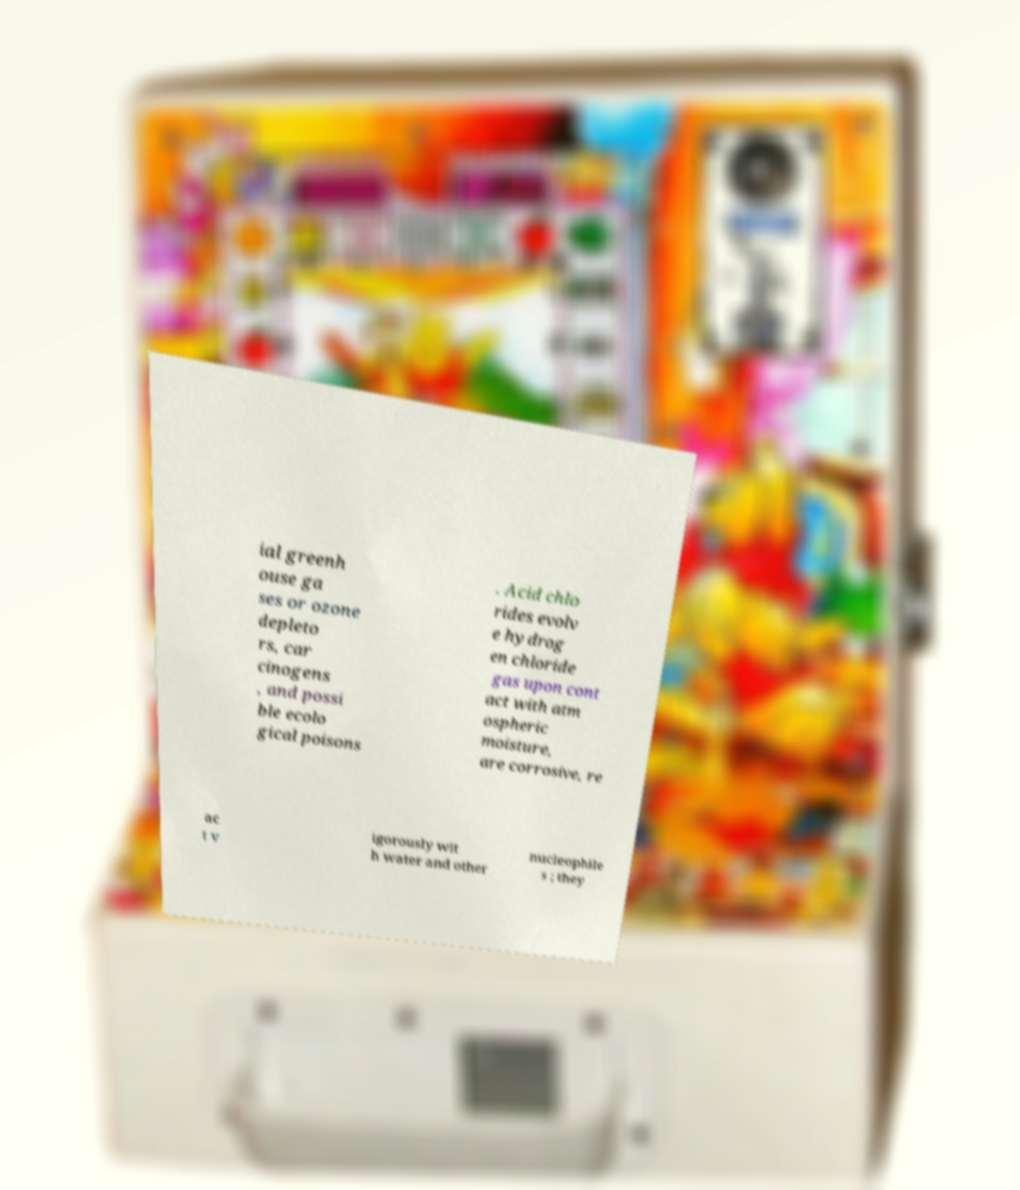Could you assist in decoding the text presented in this image and type it out clearly? ial greenh ouse ga ses or ozone depleto rs, car cinogens , and possi ble ecolo gical poisons . Acid chlo rides evolv e hydrog en chloride gas upon cont act with atm ospheric moisture, are corrosive, re ac t v igorously wit h water and other nucleophile s ; they 